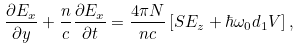<formula> <loc_0><loc_0><loc_500><loc_500>\frac { \partial E _ { x } } { \partial y } + \frac { n } { c } \frac { \partial E _ { x } } { \partial t } = \frac { 4 \pi N } { n c } \left [ S E _ { z } + \hbar { \omega } _ { 0 } d _ { 1 } V \right ] ,</formula> 